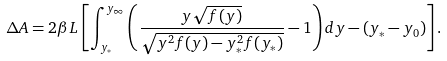Convert formula to latex. <formula><loc_0><loc_0><loc_500><loc_500>\Delta A = 2 \beta L \left [ \int _ { y _ { * } } ^ { y _ { \infty } } \left ( \frac { y \sqrt { f ( y ) } } { \sqrt { y ^ { 2 } f ( y ) - y _ { * } ^ { 2 } f ( y _ { * } ) } } - 1 \right ) d y - ( y _ { * } - y _ { 0 } ) \right ] .</formula> 